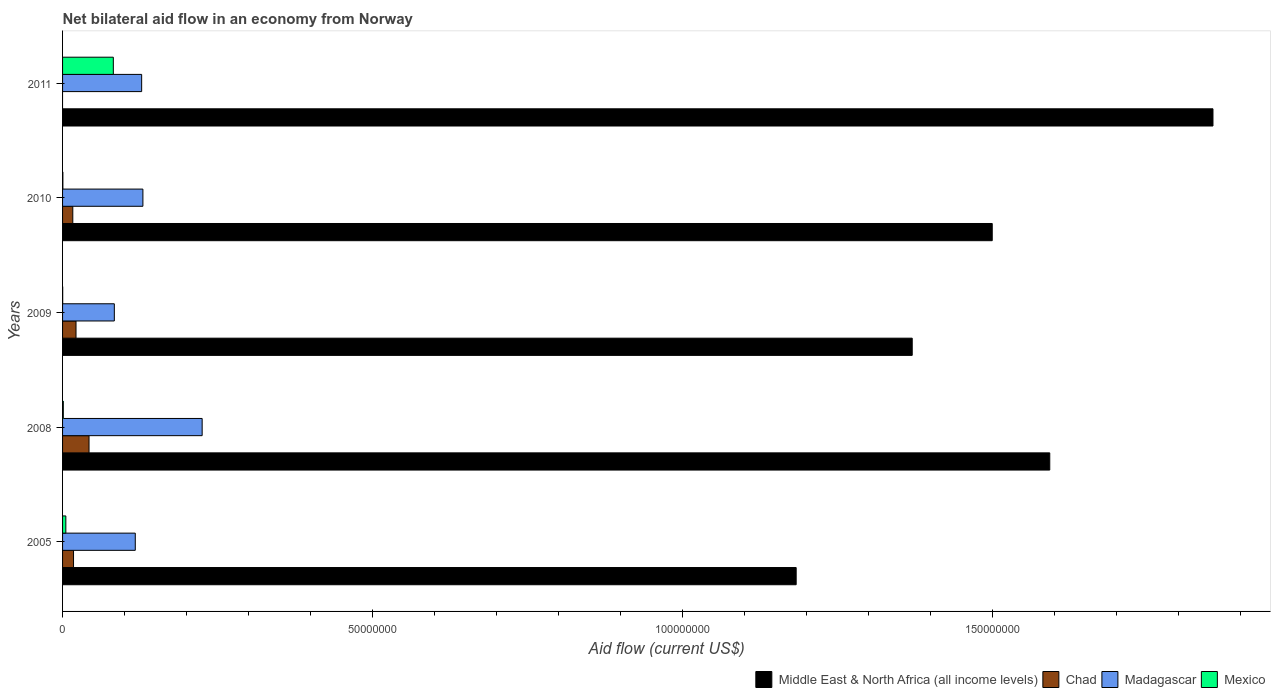How many different coloured bars are there?
Make the answer very short. 4. How many groups of bars are there?
Keep it short and to the point. 5. What is the label of the 2nd group of bars from the top?
Keep it short and to the point. 2010. What is the net bilateral aid flow in Middle East & North Africa (all income levels) in 2011?
Give a very brief answer. 1.86e+08. Across all years, what is the maximum net bilateral aid flow in Chad?
Make the answer very short. 4.27e+06. Across all years, what is the minimum net bilateral aid flow in Chad?
Provide a succinct answer. 0. In which year was the net bilateral aid flow in Mexico maximum?
Your response must be concise. 2011. What is the total net bilateral aid flow in Mexico in the graph?
Give a very brief answer. 8.91e+06. What is the difference between the net bilateral aid flow in Madagascar in 2008 and that in 2010?
Offer a terse response. 9.56e+06. What is the difference between the net bilateral aid flow in Mexico in 2005 and the net bilateral aid flow in Madagascar in 2011?
Ensure brevity in your answer.  -1.22e+07. What is the average net bilateral aid flow in Madagascar per year?
Your response must be concise. 1.37e+07. In the year 2009, what is the difference between the net bilateral aid flow in Mexico and net bilateral aid flow in Middle East & North Africa (all income levels)?
Provide a short and direct response. -1.37e+08. What is the ratio of the net bilateral aid flow in Madagascar in 2009 to that in 2010?
Give a very brief answer. 0.64. Is the net bilateral aid flow in Madagascar in 2009 less than that in 2011?
Provide a short and direct response. Yes. What is the difference between the highest and the second highest net bilateral aid flow in Mexico?
Provide a short and direct response. 7.66e+06. What is the difference between the highest and the lowest net bilateral aid flow in Chad?
Provide a short and direct response. 4.27e+06. Is it the case that in every year, the sum of the net bilateral aid flow in Middle East & North Africa (all income levels) and net bilateral aid flow in Madagascar is greater than the sum of net bilateral aid flow in Chad and net bilateral aid flow in Mexico?
Ensure brevity in your answer.  No. How many years are there in the graph?
Keep it short and to the point. 5. Are the values on the major ticks of X-axis written in scientific E-notation?
Ensure brevity in your answer.  No. Does the graph contain any zero values?
Ensure brevity in your answer.  Yes. Does the graph contain grids?
Provide a short and direct response. No. Where does the legend appear in the graph?
Your response must be concise. Bottom right. What is the title of the graph?
Ensure brevity in your answer.  Net bilateral aid flow in an economy from Norway. Does "Central Europe" appear as one of the legend labels in the graph?
Make the answer very short. No. What is the Aid flow (current US$) of Middle East & North Africa (all income levels) in 2005?
Your answer should be compact. 1.18e+08. What is the Aid flow (current US$) of Chad in 2005?
Provide a short and direct response. 1.77e+06. What is the Aid flow (current US$) of Madagascar in 2005?
Your answer should be very brief. 1.17e+07. What is the Aid flow (current US$) in Mexico in 2005?
Offer a terse response. 5.30e+05. What is the Aid flow (current US$) of Middle East & North Africa (all income levels) in 2008?
Keep it short and to the point. 1.59e+08. What is the Aid flow (current US$) of Chad in 2008?
Keep it short and to the point. 4.27e+06. What is the Aid flow (current US$) in Madagascar in 2008?
Your answer should be compact. 2.25e+07. What is the Aid flow (current US$) of Middle East & North Africa (all income levels) in 2009?
Provide a succinct answer. 1.37e+08. What is the Aid flow (current US$) of Chad in 2009?
Keep it short and to the point. 2.17e+06. What is the Aid flow (current US$) of Madagascar in 2009?
Offer a very short reply. 8.35e+06. What is the Aid flow (current US$) of Mexico in 2009?
Provide a short and direct response. 2.00e+04. What is the Aid flow (current US$) of Middle East & North Africa (all income levels) in 2010?
Keep it short and to the point. 1.50e+08. What is the Aid flow (current US$) in Chad in 2010?
Your answer should be compact. 1.65e+06. What is the Aid flow (current US$) in Madagascar in 2010?
Offer a terse response. 1.30e+07. What is the Aid flow (current US$) in Mexico in 2010?
Offer a very short reply. 5.00e+04. What is the Aid flow (current US$) of Middle East & North Africa (all income levels) in 2011?
Provide a succinct answer. 1.86e+08. What is the Aid flow (current US$) of Madagascar in 2011?
Provide a short and direct response. 1.28e+07. What is the Aid flow (current US$) in Mexico in 2011?
Offer a very short reply. 8.19e+06. Across all years, what is the maximum Aid flow (current US$) of Middle East & North Africa (all income levels)?
Your answer should be very brief. 1.86e+08. Across all years, what is the maximum Aid flow (current US$) in Chad?
Your answer should be compact. 4.27e+06. Across all years, what is the maximum Aid flow (current US$) in Madagascar?
Give a very brief answer. 2.25e+07. Across all years, what is the maximum Aid flow (current US$) of Mexico?
Keep it short and to the point. 8.19e+06. Across all years, what is the minimum Aid flow (current US$) of Middle East & North Africa (all income levels)?
Give a very brief answer. 1.18e+08. Across all years, what is the minimum Aid flow (current US$) of Chad?
Your answer should be very brief. 0. Across all years, what is the minimum Aid flow (current US$) in Madagascar?
Keep it short and to the point. 8.35e+06. Across all years, what is the minimum Aid flow (current US$) in Mexico?
Your answer should be very brief. 2.00e+04. What is the total Aid flow (current US$) of Middle East & North Africa (all income levels) in the graph?
Your answer should be very brief. 7.50e+08. What is the total Aid flow (current US$) in Chad in the graph?
Keep it short and to the point. 9.86e+06. What is the total Aid flow (current US$) in Madagascar in the graph?
Give a very brief answer. 6.83e+07. What is the total Aid flow (current US$) in Mexico in the graph?
Keep it short and to the point. 8.91e+06. What is the difference between the Aid flow (current US$) of Middle East & North Africa (all income levels) in 2005 and that in 2008?
Offer a very short reply. -4.09e+07. What is the difference between the Aid flow (current US$) in Chad in 2005 and that in 2008?
Provide a short and direct response. -2.50e+06. What is the difference between the Aid flow (current US$) of Madagascar in 2005 and that in 2008?
Offer a terse response. -1.08e+07. What is the difference between the Aid flow (current US$) of Mexico in 2005 and that in 2008?
Your response must be concise. 4.10e+05. What is the difference between the Aid flow (current US$) in Middle East & North Africa (all income levels) in 2005 and that in 2009?
Keep it short and to the point. -1.87e+07. What is the difference between the Aid flow (current US$) of Chad in 2005 and that in 2009?
Provide a succinct answer. -4.00e+05. What is the difference between the Aid flow (current US$) in Madagascar in 2005 and that in 2009?
Make the answer very short. 3.38e+06. What is the difference between the Aid flow (current US$) in Mexico in 2005 and that in 2009?
Your answer should be compact. 5.10e+05. What is the difference between the Aid flow (current US$) of Middle East & North Africa (all income levels) in 2005 and that in 2010?
Keep it short and to the point. -3.16e+07. What is the difference between the Aid flow (current US$) in Madagascar in 2005 and that in 2010?
Offer a terse response. -1.23e+06. What is the difference between the Aid flow (current US$) of Middle East & North Africa (all income levels) in 2005 and that in 2011?
Ensure brevity in your answer.  -6.72e+07. What is the difference between the Aid flow (current US$) of Madagascar in 2005 and that in 2011?
Provide a succinct answer. -1.03e+06. What is the difference between the Aid flow (current US$) in Mexico in 2005 and that in 2011?
Provide a succinct answer. -7.66e+06. What is the difference between the Aid flow (current US$) of Middle East & North Africa (all income levels) in 2008 and that in 2009?
Your answer should be compact. 2.22e+07. What is the difference between the Aid flow (current US$) of Chad in 2008 and that in 2009?
Ensure brevity in your answer.  2.10e+06. What is the difference between the Aid flow (current US$) of Madagascar in 2008 and that in 2009?
Make the answer very short. 1.42e+07. What is the difference between the Aid flow (current US$) in Mexico in 2008 and that in 2009?
Offer a terse response. 1.00e+05. What is the difference between the Aid flow (current US$) of Middle East & North Africa (all income levels) in 2008 and that in 2010?
Your answer should be compact. 9.28e+06. What is the difference between the Aid flow (current US$) in Chad in 2008 and that in 2010?
Offer a very short reply. 2.62e+06. What is the difference between the Aid flow (current US$) of Madagascar in 2008 and that in 2010?
Keep it short and to the point. 9.56e+06. What is the difference between the Aid flow (current US$) of Mexico in 2008 and that in 2010?
Make the answer very short. 7.00e+04. What is the difference between the Aid flow (current US$) in Middle East & North Africa (all income levels) in 2008 and that in 2011?
Give a very brief answer. -2.63e+07. What is the difference between the Aid flow (current US$) of Madagascar in 2008 and that in 2011?
Offer a terse response. 9.76e+06. What is the difference between the Aid flow (current US$) of Mexico in 2008 and that in 2011?
Offer a terse response. -8.07e+06. What is the difference between the Aid flow (current US$) of Middle East & North Africa (all income levels) in 2009 and that in 2010?
Provide a succinct answer. -1.29e+07. What is the difference between the Aid flow (current US$) in Chad in 2009 and that in 2010?
Give a very brief answer. 5.20e+05. What is the difference between the Aid flow (current US$) in Madagascar in 2009 and that in 2010?
Your answer should be compact. -4.61e+06. What is the difference between the Aid flow (current US$) in Mexico in 2009 and that in 2010?
Provide a short and direct response. -3.00e+04. What is the difference between the Aid flow (current US$) in Middle East & North Africa (all income levels) in 2009 and that in 2011?
Keep it short and to the point. -4.85e+07. What is the difference between the Aid flow (current US$) of Madagascar in 2009 and that in 2011?
Make the answer very short. -4.41e+06. What is the difference between the Aid flow (current US$) of Mexico in 2009 and that in 2011?
Keep it short and to the point. -8.17e+06. What is the difference between the Aid flow (current US$) of Middle East & North Africa (all income levels) in 2010 and that in 2011?
Your answer should be compact. -3.56e+07. What is the difference between the Aid flow (current US$) in Mexico in 2010 and that in 2011?
Offer a very short reply. -8.14e+06. What is the difference between the Aid flow (current US$) of Middle East & North Africa (all income levels) in 2005 and the Aid flow (current US$) of Chad in 2008?
Ensure brevity in your answer.  1.14e+08. What is the difference between the Aid flow (current US$) in Middle East & North Africa (all income levels) in 2005 and the Aid flow (current US$) in Madagascar in 2008?
Your answer should be compact. 9.58e+07. What is the difference between the Aid flow (current US$) in Middle East & North Africa (all income levels) in 2005 and the Aid flow (current US$) in Mexico in 2008?
Offer a very short reply. 1.18e+08. What is the difference between the Aid flow (current US$) of Chad in 2005 and the Aid flow (current US$) of Madagascar in 2008?
Your answer should be very brief. -2.08e+07. What is the difference between the Aid flow (current US$) of Chad in 2005 and the Aid flow (current US$) of Mexico in 2008?
Your answer should be very brief. 1.65e+06. What is the difference between the Aid flow (current US$) in Madagascar in 2005 and the Aid flow (current US$) in Mexico in 2008?
Keep it short and to the point. 1.16e+07. What is the difference between the Aid flow (current US$) in Middle East & North Africa (all income levels) in 2005 and the Aid flow (current US$) in Chad in 2009?
Your answer should be compact. 1.16e+08. What is the difference between the Aid flow (current US$) of Middle East & North Africa (all income levels) in 2005 and the Aid flow (current US$) of Madagascar in 2009?
Offer a very short reply. 1.10e+08. What is the difference between the Aid flow (current US$) of Middle East & North Africa (all income levels) in 2005 and the Aid flow (current US$) of Mexico in 2009?
Give a very brief answer. 1.18e+08. What is the difference between the Aid flow (current US$) of Chad in 2005 and the Aid flow (current US$) of Madagascar in 2009?
Provide a succinct answer. -6.58e+06. What is the difference between the Aid flow (current US$) of Chad in 2005 and the Aid flow (current US$) of Mexico in 2009?
Make the answer very short. 1.75e+06. What is the difference between the Aid flow (current US$) in Madagascar in 2005 and the Aid flow (current US$) in Mexico in 2009?
Ensure brevity in your answer.  1.17e+07. What is the difference between the Aid flow (current US$) of Middle East & North Africa (all income levels) in 2005 and the Aid flow (current US$) of Chad in 2010?
Your answer should be compact. 1.17e+08. What is the difference between the Aid flow (current US$) in Middle East & North Africa (all income levels) in 2005 and the Aid flow (current US$) in Madagascar in 2010?
Keep it short and to the point. 1.05e+08. What is the difference between the Aid flow (current US$) of Middle East & North Africa (all income levels) in 2005 and the Aid flow (current US$) of Mexico in 2010?
Ensure brevity in your answer.  1.18e+08. What is the difference between the Aid flow (current US$) in Chad in 2005 and the Aid flow (current US$) in Madagascar in 2010?
Give a very brief answer. -1.12e+07. What is the difference between the Aid flow (current US$) in Chad in 2005 and the Aid flow (current US$) in Mexico in 2010?
Give a very brief answer. 1.72e+06. What is the difference between the Aid flow (current US$) of Madagascar in 2005 and the Aid flow (current US$) of Mexico in 2010?
Give a very brief answer. 1.17e+07. What is the difference between the Aid flow (current US$) of Middle East & North Africa (all income levels) in 2005 and the Aid flow (current US$) of Madagascar in 2011?
Make the answer very short. 1.06e+08. What is the difference between the Aid flow (current US$) of Middle East & North Africa (all income levels) in 2005 and the Aid flow (current US$) of Mexico in 2011?
Your response must be concise. 1.10e+08. What is the difference between the Aid flow (current US$) in Chad in 2005 and the Aid flow (current US$) in Madagascar in 2011?
Offer a very short reply. -1.10e+07. What is the difference between the Aid flow (current US$) of Chad in 2005 and the Aid flow (current US$) of Mexico in 2011?
Your answer should be compact. -6.42e+06. What is the difference between the Aid flow (current US$) of Madagascar in 2005 and the Aid flow (current US$) of Mexico in 2011?
Ensure brevity in your answer.  3.54e+06. What is the difference between the Aid flow (current US$) in Middle East & North Africa (all income levels) in 2008 and the Aid flow (current US$) in Chad in 2009?
Ensure brevity in your answer.  1.57e+08. What is the difference between the Aid flow (current US$) in Middle East & North Africa (all income levels) in 2008 and the Aid flow (current US$) in Madagascar in 2009?
Offer a very short reply. 1.51e+08. What is the difference between the Aid flow (current US$) in Middle East & North Africa (all income levels) in 2008 and the Aid flow (current US$) in Mexico in 2009?
Give a very brief answer. 1.59e+08. What is the difference between the Aid flow (current US$) of Chad in 2008 and the Aid flow (current US$) of Madagascar in 2009?
Your answer should be very brief. -4.08e+06. What is the difference between the Aid flow (current US$) of Chad in 2008 and the Aid flow (current US$) of Mexico in 2009?
Your answer should be compact. 4.25e+06. What is the difference between the Aid flow (current US$) in Madagascar in 2008 and the Aid flow (current US$) in Mexico in 2009?
Keep it short and to the point. 2.25e+07. What is the difference between the Aid flow (current US$) in Middle East & North Africa (all income levels) in 2008 and the Aid flow (current US$) in Chad in 2010?
Offer a very short reply. 1.58e+08. What is the difference between the Aid flow (current US$) of Middle East & North Africa (all income levels) in 2008 and the Aid flow (current US$) of Madagascar in 2010?
Your answer should be very brief. 1.46e+08. What is the difference between the Aid flow (current US$) of Middle East & North Africa (all income levels) in 2008 and the Aid flow (current US$) of Mexico in 2010?
Make the answer very short. 1.59e+08. What is the difference between the Aid flow (current US$) of Chad in 2008 and the Aid flow (current US$) of Madagascar in 2010?
Provide a short and direct response. -8.69e+06. What is the difference between the Aid flow (current US$) in Chad in 2008 and the Aid flow (current US$) in Mexico in 2010?
Ensure brevity in your answer.  4.22e+06. What is the difference between the Aid flow (current US$) in Madagascar in 2008 and the Aid flow (current US$) in Mexico in 2010?
Offer a very short reply. 2.25e+07. What is the difference between the Aid flow (current US$) in Middle East & North Africa (all income levels) in 2008 and the Aid flow (current US$) in Madagascar in 2011?
Provide a short and direct response. 1.46e+08. What is the difference between the Aid flow (current US$) of Middle East & North Africa (all income levels) in 2008 and the Aid flow (current US$) of Mexico in 2011?
Your answer should be very brief. 1.51e+08. What is the difference between the Aid flow (current US$) of Chad in 2008 and the Aid flow (current US$) of Madagascar in 2011?
Offer a terse response. -8.49e+06. What is the difference between the Aid flow (current US$) in Chad in 2008 and the Aid flow (current US$) in Mexico in 2011?
Offer a very short reply. -3.92e+06. What is the difference between the Aid flow (current US$) in Madagascar in 2008 and the Aid flow (current US$) in Mexico in 2011?
Your answer should be compact. 1.43e+07. What is the difference between the Aid flow (current US$) of Middle East & North Africa (all income levels) in 2009 and the Aid flow (current US$) of Chad in 2010?
Ensure brevity in your answer.  1.35e+08. What is the difference between the Aid flow (current US$) in Middle East & North Africa (all income levels) in 2009 and the Aid flow (current US$) in Madagascar in 2010?
Ensure brevity in your answer.  1.24e+08. What is the difference between the Aid flow (current US$) of Middle East & North Africa (all income levels) in 2009 and the Aid flow (current US$) of Mexico in 2010?
Make the answer very short. 1.37e+08. What is the difference between the Aid flow (current US$) of Chad in 2009 and the Aid flow (current US$) of Madagascar in 2010?
Your response must be concise. -1.08e+07. What is the difference between the Aid flow (current US$) of Chad in 2009 and the Aid flow (current US$) of Mexico in 2010?
Keep it short and to the point. 2.12e+06. What is the difference between the Aid flow (current US$) in Madagascar in 2009 and the Aid flow (current US$) in Mexico in 2010?
Keep it short and to the point. 8.30e+06. What is the difference between the Aid flow (current US$) in Middle East & North Africa (all income levels) in 2009 and the Aid flow (current US$) in Madagascar in 2011?
Offer a very short reply. 1.24e+08. What is the difference between the Aid flow (current US$) in Middle East & North Africa (all income levels) in 2009 and the Aid flow (current US$) in Mexico in 2011?
Your answer should be compact. 1.29e+08. What is the difference between the Aid flow (current US$) of Chad in 2009 and the Aid flow (current US$) of Madagascar in 2011?
Keep it short and to the point. -1.06e+07. What is the difference between the Aid flow (current US$) in Chad in 2009 and the Aid flow (current US$) in Mexico in 2011?
Make the answer very short. -6.02e+06. What is the difference between the Aid flow (current US$) in Madagascar in 2009 and the Aid flow (current US$) in Mexico in 2011?
Keep it short and to the point. 1.60e+05. What is the difference between the Aid flow (current US$) of Middle East & North Africa (all income levels) in 2010 and the Aid flow (current US$) of Madagascar in 2011?
Keep it short and to the point. 1.37e+08. What is the difference between the Aid flow (current US$) in Middle East & North Africa (all income levels) in 2010 and the Aid flow (current US$) in Mexico in 2011?
Keep it short and to the point. 1.42e+08. What is the difference between the Aid flow (current US$) of Chad in 2010 and the Aid flow (current US$) of Madagascar in 2011?
Offer a terse response. -1.11e+07. What is the difference between the Aid flow (current US$) of Chad in 2010 and the Aid flow (current US$) of Mexico in 2011?
Ensure brevity in your answer.  -6.54e+06. What is the difference between the Aid flow (current US$) in Madagascar in 2010 and the Aid flow (current US$) in Mexico in 2011?
Offer a very short reply. 4.77e+06. What is the average Aid flow (current US$) in Middle East & North Africa (all income levels) per year?
Provide a short and direct response. 1.50e+08. What is the average Aid flow (current US$) of Chad per year?
Provide a succinct answer. 1.97e+06. What is the average Aid flow (current US$) of Madagascar per year?
Offer a very short reply. 1.37e+07. What is the average Aid flow (current US$) in Mexico per year?
Keep it short and to the point. 1.78e+06. In the year 2005, what is the difference between the Aid flow (current US$) in Middle East & North Africa (all income levels) and Aid flow (current US$) in Chad?
Make the answer very short. 1.17e+08. In the year 2005, what is the difference between the Aid flow (current US$) in Middle East & North Africa (all income levels) and Aid flow (current US$) in Madagascar?
Your response must be concise. 1.07e+08. In the year 2005, what is the difference between the Aid flow (current US$) of Middle East & North Africa (all income levels) and Aid flow (current US$) of Mexico?
Keep it short and to the point. 1.18e+08. In the year 2005, what is the difference between the Aid flow (current US$) of Chad and Aid flow (current US$) of Madagascar?
Provide a short and direct response. -9.96e+06. In the year 2005, what is the difference between the Aid flow (current US$) in Chad and Aid flow (current US$) in Mexico?
Provide a short and direct response. 1.24e+06. In the year 2005, what is the difference between the Aid flow (current US$) in Madagascar and Aid flow (current US$) in Mexico?
Make the answer very short. 1.12e+07. In the year 2008, what is the difference between the Aid flow (current US$) of Middle East & North Africa (all income levels) and Aid flow (current US$) of Chad?
Your answer should be very brief. 1.55e+08. In the year 2008, what is the difference between the Aid flow (current US$) of Middle East & North Africa (all income levels) and Aid flow (current US$) of Madagascar?
Keep it short and to the point. 1.37e+08. In the year 2008, what is the difference between the Aid flow (current US$) in Middle East & North Africa (all income levels) and Aid flow (current US$) in Mexico?
Your response must be concise. 1.59e+08. In the year 2008, what is the difference between the Aid flow (current US$) in Chad and Aid flow (current US$) in Madagascar?
Offer a very short reply. -1.82e+07. In the year 2008, what is the difference between the Aid flow (current US$) in Chad and Aid flow (current US$) in Mexico?
Offer a very short reply. 4.15e+06. In the year 2008, what is the difference between the Aid flow (current US$) in Madagascar and Aid flow (current US$) in Mexico?
Your answer should be very brief. 2.24e+07. In the year 2009, what is the difference between the Aid flow (current US$) of Middle East & North Africa (all income levels) and Aid flow (current US$) of Chad?
Give a very brief answer. 1.35e+08. In the year 2009, what is the difference between the Aid flow (current US$) of Middle East & North Africa (all income levels) and Aid flow (current US$) of Madagascar?
Offer a very short reply. 1.29e+08. In the year 2009, what is the difference between the Aid flow (current US$) of Middle East & North Africa (all income levels) and Aid flow (current US$) of Mexico?
Your answer should be very brief. 1.37e+08. In the year 2009, what is the difference between the Aid flow (current US$) of Chad and Aid flow (current US$) of Madagascar?
Your answer should be compact. -6.18e+06. In the year 2009, what is the difference between the Aid flow (current US$) of Chad and Aid flow (current US$) of Mexico?
Offer a very short reply. 2.15e+06. In the year 2009, what is the difference between the Aid flow (current US$) of Madagascar and Aid flow (current US$) of Mexico?
Your response must be concise. 8.33e+06. In the year 2010, what is the difference between the Aid flow (current US$) of Middle East & North Africa (all income levels) and Aid flow (current US$) of Chad?
Keep it short and to the point. 1.48e+08. In the year 2010, what is the difference between the Aid flow (current US$) of Middle East & North Africa (all income levels) and Aid flow (current US$) of Madagascar?
Keep it short and to the point. 1.37e+08. In the year 2010, what is the difference between the Aid flow (current US$) in Middle East & North Africa (all income levels) and Aid flow (current US$) in Mexico?
Make the answer very short. 1.50e+08. In the year 2010, what is the difference between the Aid flow (current US$) in Chad and Aid flow (current US$) in Madagascar?
Your response must be concise. -1.13e+07. In the year 2010, what is the difference between the Aid flow (current US$) in Chad and Aid flow (current US$) in Mexico?
Keep it short and to the point. 1.60e+06. In the year 2010, what is the difference between the Aid flow (current US$) of Madagascar and Aid flow (current US$) of Mexico?
Provide a succinct answer. 1.29e+07. In the year 2011, what is the difference between the Aid flow (current US$) in Middle East & North Africa (all income levels) and Aid flow (current US$) in Madagascar?
Give a very brief answer. 1.73e+08. In the year 2011, what is the difference between the Aid flow (current US$) of Middle East & North Africa (all income levels) and Aid flow (current US$) of Mexico?
Offer a terse response. 1.77e+08. In the year 2011, what is the difference between the Aid flow (current US$) of Madagascar and Aid flow (current US$) of Mexico?
Make the answer very short. 4.57e+06. What is the ratio of the Aid flow (current US$) in Middle East & North Africa (all income levels) in 2005 to that in 2008?
Keep it short and to the point. 0.74. What is the ratio of the Aid flow (current US$) of Chad in 2005 to that in 2008?
Provide a succinct answer. 0.41. What is the ratio of the Aid flow (current US$) in Madagascar in 2005 to that in 2008?
Your answer should be very brief. 0.52. What is the ratio of the Aid flow (current US$) of Mexico in 2005 to that in 2008?
Your response must be concise. 4.42. What is the ratio of the Aid flow (current US$) in Middle East & North Africa (all income levels) in 2005 to that in 2009?
Keep it short and to the point. 0.86. What is the ratio of the Aid flow (current US$) in Chad in 2005 to that in 2009?
Your answer should be compact. 0.82. What is the ratio of the Aid flow (current US$) of Madagascar in 2005 to that in 2009?
Offer a very short reply. 1.4. What is the ratio of the Aid flow (current US$) of Middle East & North Africa (all income levels) in 2005 to that in 2010?
Keep it short and to the point. 0.79. What is the ratio of the Aid flow (current US$) of Chad in 2005 to that in 2010?
Your answer should be compact. 1.07. What is the ratio of the Aid flow (current US$) in Madagascar in 2005 to that in 2010?
Provide a succinct answer. 0.91. What is the ratio of the Aid flow (current US$) in Mexico in 2005 to that in 2010?
Your answer should be compact. 10.6. What is the ratio of the Aid flow (current US$) of Middle East & North Africa (all income levels) in 2005 to that in 2011?
Provide a succinct answer. 0.64. What is the ratio of the Aid flow (current US$) of Madagascar in 2005 to that in 2011?
Ensure brevity in your answer.  0.92. What is the ratio of the Aid flow (current US$) of Mexico in 2005 to that in 2011?
Your response must be concise. 0.06. What is the ratio of the Aid flow (current US$) of Middle East & North Africa (all income levels) in 2008 to that in 2009?
Offer a very short reply. 1.16. What is the ratio of the Aid flow (current US$) of Chad in 2008 to that in 2009?
Provide a short and direct response. 1.97. What is the ratio of the Aid flow (current US$) in Madagascar in 2008 to that in 2009?
Provide a short and direct response. 2.7. What is the ratio of the Aid flow (current US$) of Mexico in 2008 to that in 2009?
Give a very brief answer. 6. What is the ratio of the Aid flow (current US$) in Middle East & North Africa (all income levels) in 2008 to that in 2010?
Your answer should be very brief. 1.06. What is the ratio of the Aid flow (current US$) in Chad in 2008 to that in 2010?
Your answer should be compact. 2.59. What is the ratio of the Aid flow (current US$) of Madagascar in 2008 to that in 2010?
Your answer should be compact. 1.74. What is the ratio of the Aid flow (current US$) in Mexico in 2008 to that in 2010?
Give a very brief answer. 2.4. What is the ratio of the Aid flow (current US$) in Middle East & North Africa (all income levels) in 2008 to that in 2011?
Provide a succinct answer. 0.86. What is the ratio of the Aid flow (current US$) of Madagascar in 2008 to that in 2011?
Offer a terse response. 1.76. What is the ratio of the Aid flow (current US$) in Mexico in 2008 to that in 2011?
Provide a short and direct response. 0.01. What is the ratio of the Aid flow (current US$) in Middle East & North Africa (all income levels) in 2009 to that in 2010?
Ensure brevity in your answer.  0.91. What is the ratio of the Aid flow (current US$) in Chad in 2009 to that in 2010?
Give a very brief answer. 1.32. What is the ratio of the Aid flow (current US$) in Madagascar in 2009 to that in 2010?
Ensure brevity in your answer.  0.64. What is the ratio of the Aid flow (current US$) of Middle East & North Africa (all income levels) in 2009 to that in 2011?
Provide a succinct answer. 0.74. What is the ratio of the Aid flow (current US$) in Madagascar in 2009 to that in 2011?
Give a very brief answer. 0.65. What is the ratio of the Aid flow (current US$) of Mexico in 2009 to that in 2011?
Offer a very short reply. 0. What is the ratio of the Aid flow (current US$) in Middle East & North Africa (all income levels) in 2010 to that in 2011?
Your answer should be very brief. 0.81. What is the ratio of the Aid flow (current US$) in Madagascar in 2010 to that in 2011?
Offer a terse response. 1.02. What is the ratio of the Aid flow (current US$) of Mexico in 2010 to that in 2011?
Offer a very short reply. 0.01. What is the difference between the highest and the second highest Aid flow (current US$) of Middle East & North Africa (all income levels)?
Your answer should be compact. 2.63e+07. What is the difference between the highest and the second highest Aid flow (current US$) of Chad?
Your answer should be very brief. 2.10e+06. What is the difference between the highest and the second highest Aid flow (current US$) in Madagascar?
Provide a short and direct response. 9.56e+06. What is the difference between the highest and the second highest Aid flow (current US$) of Mexico?
Offer a very short reply. 7.66e+06. What is the difference between the highest and the lowest Aid flow (current US$) in Middle East & North Africa (all income levels)?
Provide a succinct answer. 6.72e+07. What is the difference between the highest and the lowest Aid flow (current US$) of Chad?
Your answer should be compact. 4.27e+06. What is the difference between the highest and the lowest Aid flow (current US$) of Madagascar?
Provide a short and direct response. 1.42e+07. What is the difference between the highest and the lowest Aid flow (current US$) of Mexico?
Your response must be concise. 8.17e+06. 